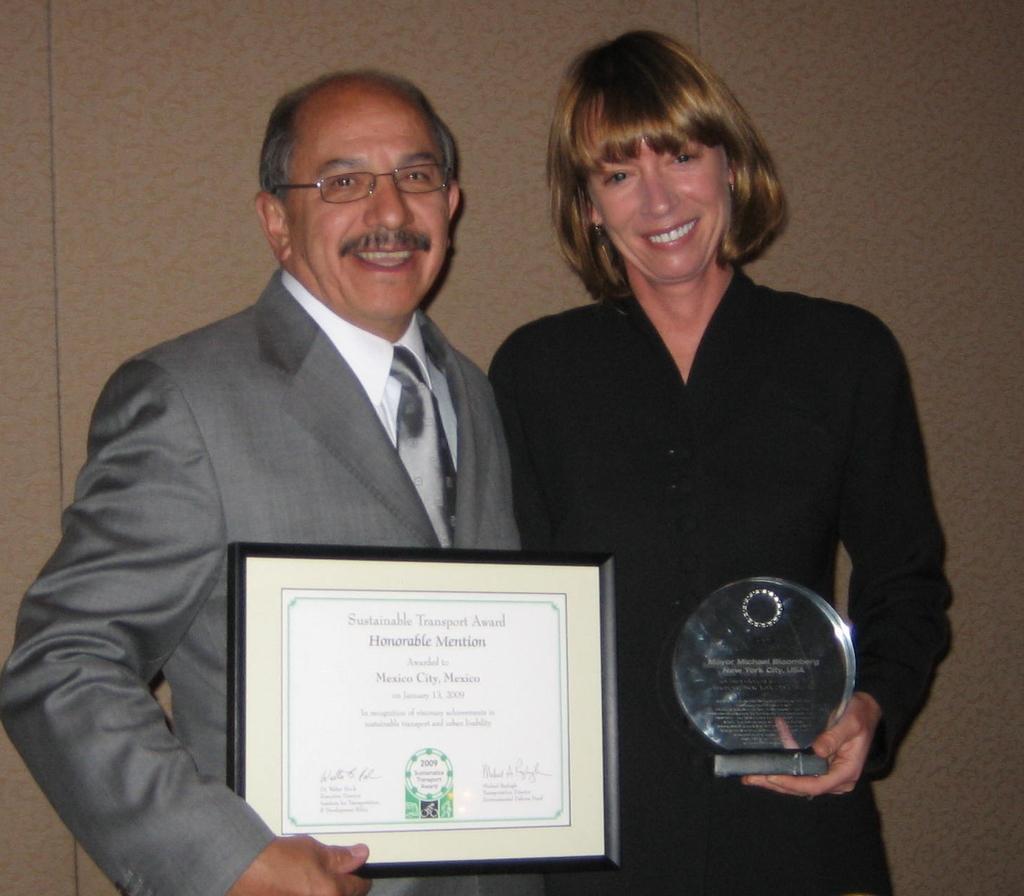In one or two sentences, can you explain what this image depicts? In this picture there is a man who is holding a certificate, beside him there is a woman who is wearing black dress and holding a prize. Both of them are smiling and standing near to the wall. 